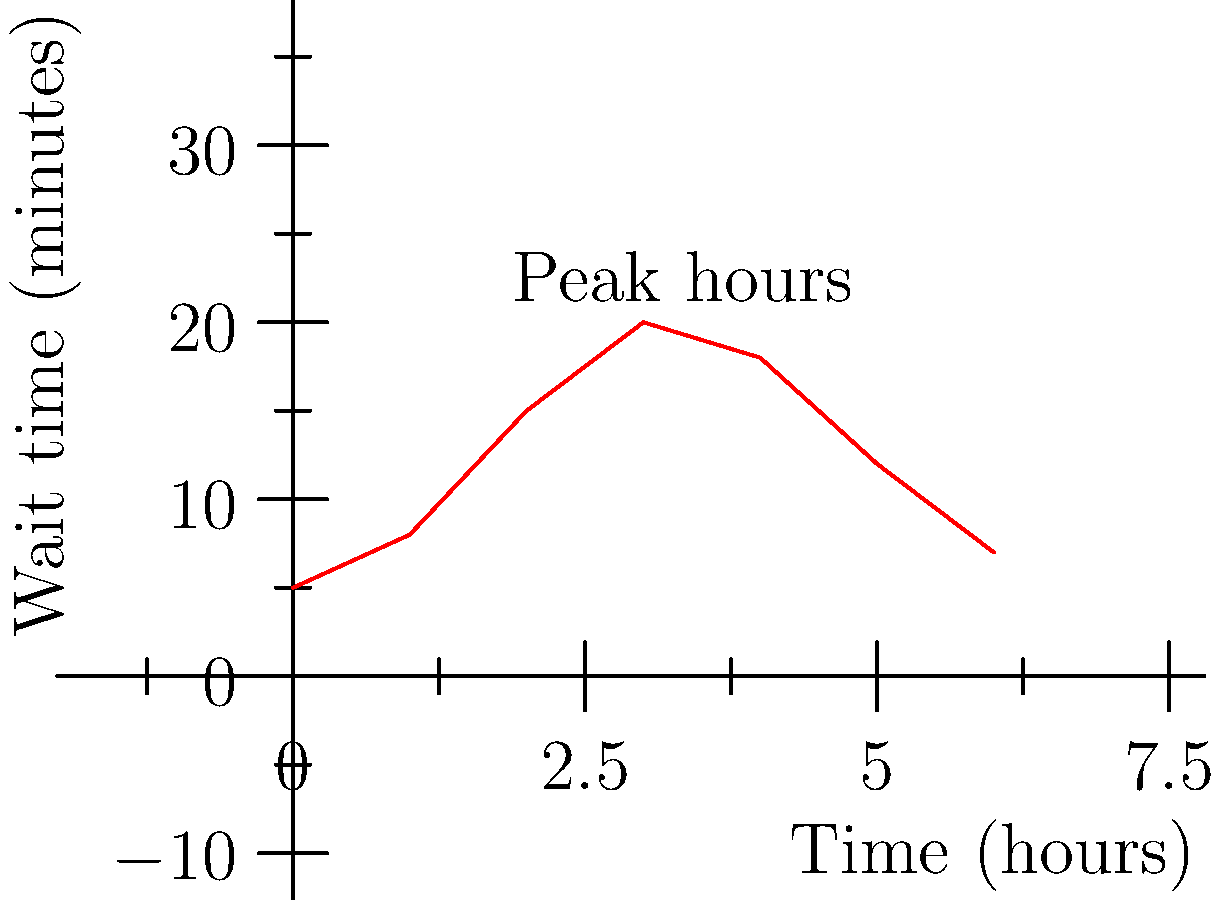Based on the line graph showing customer wait times during peak hours, what strategy could you implement to reduce the maximum wait time by approximately 25% without significantly impacting your loyal customers? To answer this question, let's analyze the graph step-by-step:

1. Identify the peak wait time:
   The maximum wait time occurs at the 3-hour mark, reaching 20 minutes.

2. Calculate the target wait time (25% reduction):
   Target wait time = 20 minutes × (1 - 0.25) = 15 minutes

3. Observe the pattern:
   - Wait times increase sharply from 1-3 hours
   - They remain high from 3-4 hours
   - They decrease from 4-6 hours

4. Consider potential strategies:
   a) Increase staffing during peak hours (2-4 hour mark)
   b) Prepare more food in advance for quick service
   c) Implement a pre-order system for loyal customers

5. Evaluate the impact on loyal customers:
   - Loyal customers, like the retired teacher, should not be negatively affected
   - A pre-order system would benefit loyal customers while reducing overall wait times

6. Formulate the answer:
   Implement a pre-order system for loyal customers and prepare more food in advance. This strategy would reduce the maximum wait time for regular customers while ensuring loyal customers, like the retired teacher, receive preferential treatment.
Answer: Implement pre-order system and prepare more food in advance 